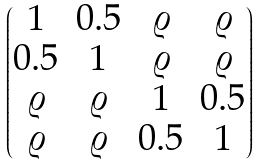Convert formula to latex. <formula><loc_0><loc_0><loc_500><loc_500>\begin{pmatrix} 1 & 0 . 5 & \varrho & \varrho \\ 0 . 5 & 1 & \varrho & \varrho \\ \varrho & \varrho & 1 & 0 . 5 \\ \varrho & \varrho & 0 . 5 & 1 \end{pmatrix}</formula> 